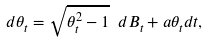<formula> <loc_0><loc_0><loc_500><loc_500>d \theta _ { t } = \sqrt { \theta _ { t } ^ { 2 } - 1 } \ d B _ { t } + a \theta _ { t } d t ,</formula> 